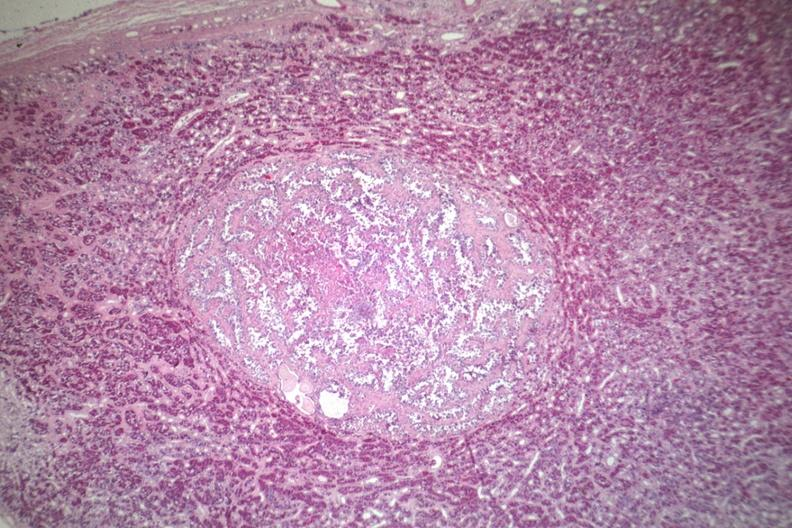does this image show well circumscribed papillary lesion see for high mag?
Answer the question using a single word or phrase. Yes 